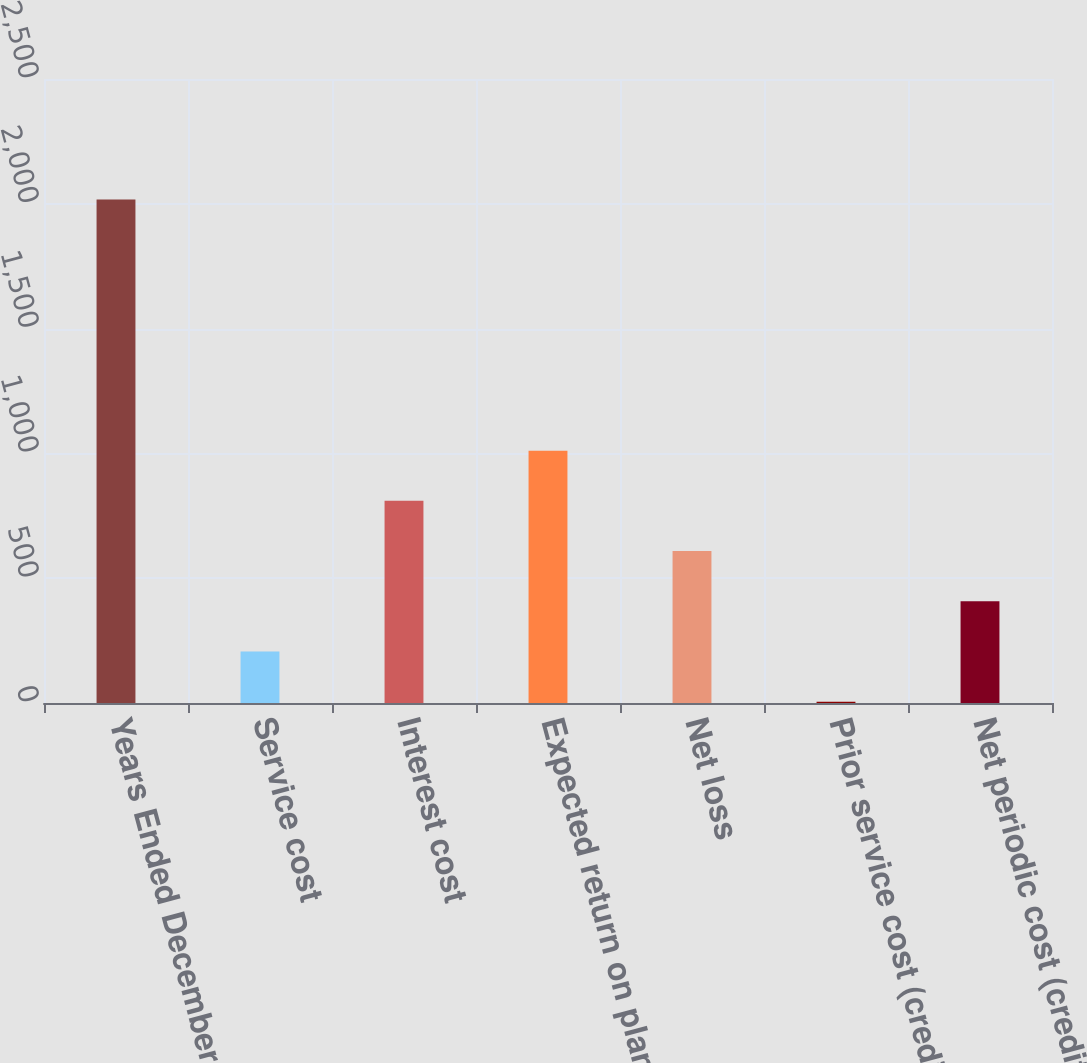Convert chart. <chart><loc_0><loc_0><loc_500><loc_500><bar_chart><fcel>Years Ended December 31<fcel>Service cost<fcel>Interest cost<fcel>Expected return on plan assets<fcel>Net loss<fcel>Prior service cost (credit)<fcel>Net periodic cost (credit)<nl><fcel>2017<fcel>206.2<fcel>809.8<fcel>1011<fcel>608.6<fcel>5<fcel>407.4<nl></chart> 